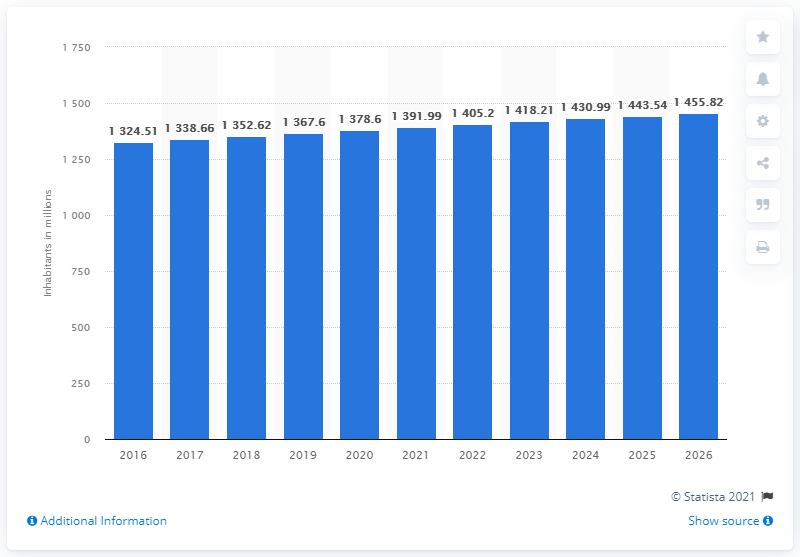Outline some significant characteristics in this image. As of 2020, the population of India was approximately 1391.99 million people. 